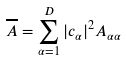Convert formula to latex. <formula><loc_0><loc_0><loc_500><loc_500>\overline { A } = \sum _ { \alpha = 1 } ^ { D } | c _ { \alpha } | ^ { 2 } A _ { \alpha \alpha }</formula> 